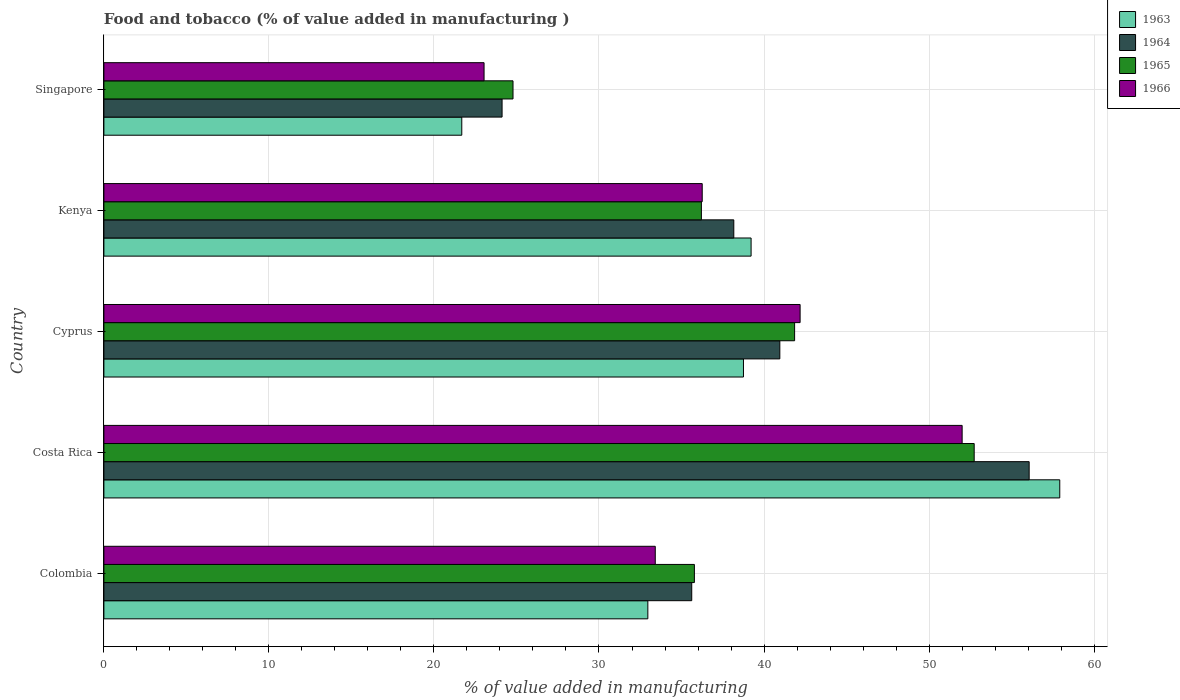How many different coloured bars are there?
Make the answer very short. 4. How many groups of bars are there?
Offer a terse response. 5. How many bars are there on the 5th tick from the top?
Provide a short and direct response. 4. How many bars are there on the 2nd tick from the bottom?
Make the answer very short. 4. What is the label of the 4th group of bars from the top?
Offer a very short reply. Costa Rica. What is the value added in manufacturing food and tobacco in 1963 in Kenya?
Make the answer very short. 39.22. Across all countries, what is the maximum value added in manufacturing food and tobacco in 1965?
Offer a terse response. 52.73. Across all countries, what is the minimum value added in manufacturing food and tobacco in 1963?
Give a very brief answer. 21.69. In which country was the value added in manufacturing food and tobacco in 1966 minimum?
Offer a terse response. Singapore. What is the total value added in manufacturing food and tobacco in 1963 in the graph?
Your response must be concise. 190.54. What is the difference between the value added in manufacturing food and tobacco in 1965 in Costa Rica and that in Kenya?
Ensure brevity in your answer.  16.53. What is the difference between the value added in manufacturing food and tobacco in 1966 in Kenya and the value added in manufacturing food and tobacco in 1964 in Costa Rica?
Make the answer very short. -19.81. What is the average value added in manufacturing food and tobacco in 1964 per country?
Make the answer very short. 38.99. What is the difference between the value added in manufacturing food and tobacco in 1964 and value added in manufacturing food and tobacco in 1965 in Costa Rica?
Your answer should be compact. 3.33. In how many countries, is the value added in manufacturing food and tobacco in 1964 greater than 38 %?
Offer a very short reply. 3. What is the ratio of the value added in manufacturing food and tobacco in 1964 in Cyprus to that in Kenya?
Your response must be concise. 1.07. Is the value added in manufacturing food and tobacco in 1963 in Costa Rica less than that in Kenya?
Offer a very short reply. No. What is the difference between the highest and the second highest value added in manufacturing food and tobacco in 1965?
Provide a succinct answer. 10.88. What is the difference between the highest and the lowest value added in manufacturing food and tobacco in 1964?
Provide a short and direct response. 31.94. What does the 4th bar from the top in Cyprus represents?
Give a very brief answer. 1963. What does the 4th bar from the bottom in Colombia represents?
Provide a succinct answer. 1966. Is it the case that in every country, the sum of the value added in manufacturing food and tobacco in 1963 and value added in manufacturing food and tobacco in 1964 is greater than the value added in manufacturing food and tobacco in 1966?
Give a very brief answer. Yes. How many bars are there?
Make the answer very short. 20. Are all the bars in the graph horizontal?
Your response must be concise. Yes. What is the difference between two consecutive major ticks on the X-axis?
Your answer should be compact. 10. Does the graph contain any zero values?
Offer a terse response. No. Where does the legend appear in the graph?
Make the answer very short. Top right. What is the title of the graph?
Make the answer very short. Food and tobacco (% of value added in manufacturing ). Does "1963" appear as one of the legend labels in the graph?
Make the answer very short. Yes. What is the label or title of the X-axis?
Keep it short and to the point. % of value added in manufacturing. What is the label or title of the Y-axis?
Provide a succinct answer. Country. What is the % of value added in manufacturing in 1963 in Colombia?
Your answer should be very brief. 32.96. What is the % of value added in manufacturing of 1964 in Colombia?
Make the answer very short. 35.62. What is the % of value added in manufacturing of 1965 in Colombia?
Your response must be concise. 35.78. What is the % of value added in manufacturing of 1966 in Colombia?
Provide a short and direct response. 33.41. What is the % of value added in manufacturing of 1963 in Costa Rica?
Make the answer very short. 57.92. What is the % of value added in manufacturing of 1964 in Costa Rica?
Make the answer very short. 56.07. What is the % of value added in manufacturing in 1965 in Costa Rica?
Your answer should be very brief. 52.73. What is the % of value added in manufacturing in 1966 in Costa Rica?
Provide a succinct answer. 52. What is the % of value added in manufacturing of 1963 in Cyprus?
Make the answer very short. 38.75. What is the % of value added in manufacturing of 1964 in Cyprus?
Your answer should be compact. 40.96. What is the % of value added in manufacturing in 1965 in Cyprus?
Provide a succinct answer. 41.85. What is the % of value added in manufacturing of 1966 in Cyprus?
Your answer should be compact. 42.19. What is the % of value added in manufacturing in 1963 in Kenya?
Give a very brief answer. 39.22. What is the % of value added in manufacturing of 1964 in Kenya?
Offer a terse response. 38.17. What is the % of value added in manufacturing of 1965 in Kenya?
Your response must be concise. 36.2. What is the % of value added in manufacturing of 1966 in Kenya?
Offer a terse response. 36.25. What is the % of value added in manufacturing of 1963 in Singapore?
Keep it short and to the point. 21.69. What is the % of value added in manufacturing in 1964 in Singapore?
Make the answer very short. 24.13. What is the % of value added in manufacturing of 1965 in Singapore?
Provide a short and direct response. 24.79. What is the % of value added in manufacturing in 1966 in Singapore?
Give a very brief answer. 23.04. Across all countries, what is the maximum % of value added in manufacturing of 1963?
Offer a terse response. 57.92. Across all countries, what is the maximum % of value added in manufacturing of 1964?
Provide a short and direct response. 56.07. Across all countries, what is the maximum % of value added in manufacturing in 1965?
Your answer should be compact. 52.73. Across all countries, what is the maximum % of value added in manufacturing of 1966?
Offer a terse response. 52. Across all countries, what is the minimum % of value added in manufacturing of 1963?
Your response must be concise. 21.69. Across all countries, what is the minimum % of value added in manufacturing in 1964?
Make the answer very short. 24.13. Across all countries, what is the minimum % of value added in manufacturing in 1965?
Your answer should be compact. 24.79. Across all countries, what is the minimum % of value added in manufacturing of 1966?
Offer a terse response. 23.04. What is the total % of value added in manufacturing of 1963 in the graph?
Offer a terse response. 190.54. What is the total % of value added in manufacturing in 1964 in the graph?
Make the answer very short. 194.94. What is the total % of value added in manufacturing of 1965 in the graph?
Keep it short and to the point. 191.36. What is the total % of value added in manufacturing of 1966 in the graph?
Your answer should be compact. 186.89. What is the difference between the % of value added in manufacturing in 1963 in Colombia and that in Costa Rica?
Provide a short and direct response. -24.96. What is the difference between the % of value added in manufacturing of 1964 in Colombia and that in Costa Rica?
Provide a succinct answer. -20.45. What is the difference between the % of value added in manufacturing of 1965 in Colombia and that in Costa Rica?
Give a very brief answer. -16.95. What is the difference between the % of value added in manufacturing in 1966 in Colombia and that in Costa Rica?
Provide a succinct answer. -18.59. What is the difference between the % of value added in manufacturing of 1963 in Colombia and that in Cyprus?
Offer a very short reply. -5.79. What is the difference between the % of value added in manufacturing of 1964 in Colombia and that in Cyprus?
Offer a very short reply. -5.34. What is the difference between the % of value added in manufacturing of 1965 in Colombia and that in Cyprus?
Give a very brief answer. -6.07. What is the difference between the % of value added in manufacturing in 1966 in Colombia and that in Cyprus?
Provide a succinct answer. -8.78. What is the difference between the % of value added in manufacturing in 1963 in Colombia and that in Kenya?
Offer a very short reply. -6.26. What is the difference between the % of value added in manufacturing in 1964 in Colombia and that in Kenya?
Offer a terse response. -2.55. What is the difference between the % of value added in manufacturing in 1965 in Colombia and that in Kenya?
Give a very brief answer. -0.42. What is the difference between the % of value added in manufacturing of 1966 in Colombia and that in Kenya?
Ensure brevity in your answer.  -2.84. What is the difference between the % of value added in manufacturing of 1963 in Colombia and that in Singapore?
Make the answer very short. 11.27. What is the difference between the % of value added in manufacturing of 1964 in Colombia and that in Singapore?
Provide a succinct answer. 11.49. What is the difference between the % of value added in manufacturing in 1965 in Colombia and that in Singapore?
Ensure brevity in your answer.  10.99. What is the difference between the % of value added in manufacturing in 1966 in Colombia and that in Singapore?
Your answer should be compact. 10.37. What is the difference between the % of value added in manufacturing in 1963 in Costa Rica and that in Cyprus?
Give a very brief answer. 19.17. What is the difference between the % of value added in manufacturing of 1964 in Costa Rica and that in Cyprus?
Offer a terse response. 15.11. What is the difference between the % of value added in manufacturing of 1965 in Costa Rica and that in Cyprus?
Provide a succinct answer. 10.88. What is the difference between the % of value added in manufacturing of 1966 in Costa Rica and that in Cyprus?
Keep it short and to the point. 9.82. What is the difference between the % of value added in manufacturing in 1963 in Costa Rica and that in Kenya?
Your response must be concise. 18.7. What is the difference between the % of value added in manufacturing in 1964 in Costa Rica and that in Kenya?
Offer a terse response. 17.9. What is the difference between the % of value added in manufacturing in 1965 in Costa Rica and that in Kenya?
Make the answer very short. 16.53. What is the difference between the % of value added in manufacturing in 1966 in Costa Rica and that in Kenya?
Ensure brevity in your answer.  15.75. What is the difference between the % of value added in manufacturing in 1963 in Costa Rica and that in Singapore?
Make the answer very short. 36.23. What is the difference between the % of value added in manufacturing of 1964 in Costa Rica and that in Singapore?
Give a very brief answer. 31.94. What is the difference between the % of value added in manufacturing of 1965 in Costa Rica and that in Singapore?
Provide a succinct answer. 27.94. What is the difference between the % of value added in manufacturing of 1966 in Costa Rica and that in Singapore?
Give a very brief answer. 28.97. What is the difference between the % of value added in manufacturing of 1963 in Cyprus and that in Kenya?
Give a very brief answer. -0.46. What is the difference between the % of value added in manufacturing in 1964 in Cyprus and that in Kenya?
Offer a very short reply. 2.79. What is the difference between the % of value added in manufacturing of 1965 in Cyprus and that in Kenya?
Give a very brief answer. 5.65. What is the difference between the % of value added in manufacturing in 1966 in Cyprus and that in Kenya?
Your answer should be compact. 5.93. What is the difference between the % of value added in manufacturing in 1963 in Cyprus and that in Singapore?
Keep it short and to the point. 17.07. What is the difference between the % of value added in manufacturing in 1964 in Cyprus and that in Singapore?
Offer a terse response. 16.83. What is the difference between the % of value added in manufacturing in 1965 in Cyprus and that in Singapore?
Your response must be concise. 17.06. What is the difference between the % of value added in manufacturing in 1966 in Cyprus and that in Singapore?
Provide a succinct answer. 19.15. What is the difference between the % of value added in manufacturing in 1963 in Kenya and that in Singapore?
Make the answer very short. 17.53. What is the difference between the % of value added in manufacturing of 1964 in Kenya and that in Singapore?
Offer a terse response. 14.04. What is the difference between the % of value added in manufacturing in 1965 in Kenya and that in Singapore?
Your answer should be very brief. 11.41. What is the difference between the % of value added in manufacturing of 1966 in Kenya and that in Singapore?
Offer a terse response. 13.22. What is the difference between the % of value added in manufacturing in 1963 in Colombia and the % of value added in manufacturing in 1964 in Costa Rica?
Your response must be concise. -23.11. What is the difference between the % of value added in manufacturing of 1963 in Colombia and the % of value added in manufacturing of 1965 in Costa Rica?
Your answer should be very brief. -19.77. What is the difference between the % of value added in manufacturing in 1963 in Colombia and the % of value added in manufacturing in 1966 in Costa Rica?
Provide a short and direct response. -19.04. What is the difference between the % of value added in manufacturing in 1964 in Colombia and the % of value added in manufacturing in 1965 in Costa Rica?
Give a very brief answer. -17.11. What is the difference between the % of value added in manufacturing of 1964 in Colombia and the % of value added in manufacturing of 1966 in Costa Rica?
Offer a very short reply. -16.38. What is the difference between the % of value added in manufacturing in 1965 in Colombia and the % of value added in manufacturing in 1966 in Costa Rica?
Ensure brevity in your answer.  -16.22. What is the difference between the % of value added in manufacturing in 1963 in Colombia and the % of value added in manufacturing in 1964 in Cyprus?
Your answer should be compact. -8. What is the difference between the % of value added in manufacturing of 1963 in Colombia and the % of value added in manufacturing of 1965 in Cyprus?
Keep it short and to the point. -8.89. What is the difference between the % of value added in manufacturing of 1963 in Colombia and the % of value added in manufacturing of 1966 in Cyprus?
Your answer should be compact. -9.23. What is the difference between the % of value added in manufacturing of 1964 in Colombia and the % of value added in manufacturing of 1965 in Cyprus?
Your answer should be compact. -6.23. What is the difference between the % of value added in manufacturing of 1964 in Colombia and the % of value added in manufacturing of 1966 in Cyprus?
Ensure brevity in your answer.  -6.57. What is the difference between the % of value added in manufacturing of 1965 in Colombia and the % of value added in manufacturing of 1966 in Cyprus?
Ensure brevity in your answer.  -6.41. What is the difference between the % of value added in manufacturing in 1963 in Colombia and the % of value added in manufacturing in 1964 in Kenya?
Keep it short and to the point. -5.21. What is the difference between the % of value added in manufacturing in 1963 in Colombia and the % of value added in manufacturing in 1965 in Kenya?
Give a very brief answer. -3.24. What is the difference between the % of value added in manufacturing in 1963 in Colombia and the % of value added in manufacturing in 1966 in Kenya?
Ensure brevity in your answer.  -3.29. What is the difference between the % of value added in manufacturing of 1964 in Colombia and the % of value added in manufacturing of 1965 in Kenya?
Provide a short and direct response. -0.58. What is the difference between the % of value added in manufacturing in 1964 in Colombia and the % of value added in manufacturing in 1966 in Kenya?
Offer a very short reply. -0.63. What is the difference between the % of value added in manufacturing in 1965 in Colombia and the % of value added in manufacturing in 1966 in Kenya?
Provide a short and direct response. -0.47. What is the difference between the % of value added in manufacturing in 1963 in Colombia and the % of value added in manufacturing in 1964 in Singapore?
Make the answer very short. 8.83. What is the difference between the % of value added in manufacturing of 1963 in Colombia and the % of value added in manufacturing of 1965 in Singapore?
Offer a terse response. 8.17. What is the difference between the % of value added in manufacturing of 1963 in Colombia and the % of value added in manufacturing of 1966 in Singapore?
Your answer should be very brief. 9.92. What is the difference between the % of value added in manufacturing in 1964 in Colombia and the % of value added in manufacturing in 1965 in Singapore?
Your answer should be compact. 10.83. What is the difference between the % of value added in manufacturing in 1964 in Colombia and the % of value added in manufacturing in 1966 in Singapore?
Provide a succinct answer. 12.58. What is the difference between the % of value added in manufacturing of 1965 in Colombia and the % of value added in manufacturing of 1966 in Singapore?
Offer a terse response. 12.74. What is the difference between the % of value added in manufacturing in 1963 in Costa Rica and the % of value added in manufacturing in 1964 in Cyprus?
Provide a short and direct response. 16.96. What is the difference between the % of value added in manufacturing of 1963 in Costa Rica and the % of value added in manufacturing of 1965 in Cyprus?
Ensure brevity in your answer.  16.07. What is the difference between the % of value added in manufacturing in 1963 in Costa Rica and the % of value added in manufacturing in 1966 in Cyprus?
Offer a very short reply. 15.73. What is the difference between the % of value added in manufacturing of 1964 in Costa Rica and the % of value added in manufacturing of 1965 in Cyprus?
Ensure brevity in your answer.  14.21. What is the difference between the % of value added in manufacturing of 1964 in Costa Rica and the % of value added in manufacturing of 1966 in Cyprus?
Your response must be concise. 13.88. What is the difference between the % of value added in manufacturing of 1965 in Costa Rica and the % of value added in manufacturing of 1966 in Cyprus?
Offer a terse response. 10.55. What is the difference between the % of value added in manufacturing of 1963 in Costa Rica and the % of value added in manufacturing of 1964 in Kenya?
Your answer should be compact. 19.75. What is the difference between the % of value added in manufacturing of 1963 in Costa Rica and the % of value added in manufacturing of 1965 in Kenya?
Keep it short and to the point. 21.72. What is the difference between the % of value added in manufacturing in 1963 in Costa Rica and the % of value added in manufacturing in 1966 in Kenya?
Your answer should be very brief. 21.67. What is the difference between the % of value added in manufacturing of 1964 in Costa Rica and the % of value added in manufacturing of 1965 in Kenya?
Keep it short and to the point. 19.86. What is the difference between the % of value added in manufacturing in 1964 in Costa Rica and the % of value added in manufacturing in 1966 in Kenya?
Make the answer very short. 19.81. What is the difference between the % of value added in manufacturing of 1965 in Costa Rica and the % of value added in manufacturing of 1966 in Kenya?
Provide a succinct answer. 16.48. What is the difference between the % of value added in manufacturing of 1963 in Costa Rica and the % of value added in manufacturing of 1964 in Singapore?
Keep it short and to the point. 33.79. What is the difference between the % of value added in manufacturing in 1963 in Costa Rica and the % of value added in manufacturing in 1965 in Singapore?
Give a very brief answer. 33.13. What is the difference between the % of value added in manufacturing of 1963 in Costa Rica and the % of value added in manufacturing of 1966 in Singapore?
Provide a succinct answer. 34.88. What is the difference between the % of value added in manufacturing in 1964 in Costa Rica and the % of value added in manufacturing in 1965 in Singapore?
Your answer should be compact. 31.28. What is the difference between the % of value added in manufacturing of 1964 in Costa Rica and the % of value added in manufacturing of 1966 in Singapore?
Your response must be concise. 33.03. What is the difference between the % of value added in manufacturing in 1965 in Costa Rica and the % of value added in manufacturing in 1966 in Singapore?
Give a very brief answer. 29.7. What is the difference between the % of value added in manufacturing of 1963 in Cyprus and the % of value added in manufacturing of 1964 in Kenya?
Your answer should be compact. 0.59. What is the difference between the % of value added in manufacturing of 1963 in Cyprus and the % of value added in manufacturing of 1965 in Kenya?
Offer a very short reply. 2.55. What is the difference between the % of value added in manufacturing in 1963 in Cyprus and the % of value added in manufacturing in 1966 in Kenya?
Keep it short and to the point. 2.5. What is the difference between the % of value added in manufacturing of 1964 in Cyprus and the % of value added in manufacturing of 1965 in Kenya?
Keep it short and to the point. 4.75. What is the difference between the % of value added in manufacturing of 1964 in Cyprus and the % of value added in manufacturing of 1966 in Kenya?
Ensure brevity in your answer.  4.7. What is the difference between the % of value added in manufacturing in 1965 in Cyprus and the % of value added in manufacturing in 1966 in Kenya?
Provide a short and direct response. 5.6. What is the difference between the % of value added in manufacturing in 1963 in Cyprus and the % of value added in manufacturing in 1964 in Singapore?
Your response must be concise. 14.63. What is the difference between the % of value added in manufacturing of 1963 in Cyprus and the % of value added in manufacturing of 1965 in Singapore?
Ensure brevity in your answer.  13.96. What is the difference between the % of value added in manufacturing of 1963 in Cyprus and the % of value added in manufacturing of 1966 in Singapore?
Provide a short and direct response. 15.72. What is the difference between the % of value added in manufacturing of 1964 in Cyprus and the % of value added in manufacturing of 1965 in Singapore?
Give a very brief answer. 16.17. What is the difference between the % of value added in manufacturing of 1964 in Cyprus and the % of value added in manufacturing of 1966 in Singapore?
Your response must be concise. 17.92. What is the difference between the % of value added in manufacturing of 1965 in Cyprus and the % of value added in manufacturing of 1966 in Singapore?
Ensure brevity in your answer.  18.82. What is the difference between the % of value added in manufacturing in 1963 in Kenya and the % of value added in manufacturing in 1964 in Singapore?
Your answer should be compact. 15.09. What is the difference between the % of value added in manufacturing in 1963 in Kenya and the % of value added in manufacturing in 1965 in Singapore?
Ensure brevity in your answer.  14.43. What is the difference between the % of value added in manufacturing in 1963 in Kenya and the % of value added in manufacturing in 1966 in Singapore?
Offer a very short reply. 16.18. What is the difference between the % of value added in manufacturing of 1964 in Kenya and the % of value added in manufacturing of 1965 in Singapore?
Ensure brevity in your answer.  13.38. What is the difference between the % of value added in manufacturing in 1964 in Kenya and the % of value added in manufacturing in 1966 in Singapore?
Offer a terse response. 15.13. What is the difference between the % of value added in manufacturing of 1965 in Kenya and the % of value added in manufacturing of 1966 in Singapore?
Give a very brief answer. 13.17. What is the average % of value added in manufacturing in 1963 per country?
Keep it short and to the point. 38.11. What is the average % of value added in manufacturing in 1964 per country?
Your response must be concise. 38.99. What is the average % of value added in manufacturing in 1965 per country?
Give a very brief answer. 38.27. What is the average % of value added in manufacturing of 1966 per country?
Give a very brief answer. 37.38. What is the difference between the % of value added in manufacturing in 1963 and % of value added in manufacturing in 1964 in Colombia?
Keep it short and to the point. -2.66. What is the difference between the % of value added in manufacturing of 1963 and % of value added in manufacturing of 1965 in Colombia?
Keep it short and to the point. -2.82. What is the difference between the % of value added in manufacturing of 1963 and % of value added in manufacturing of 1966 in Colombia?
Your response must be concise. -0.45. What is the difference between the % of value added in manufacturing in 1964 and % of value added in manufacturing in 1965 in Colombia?
Give a very brief answer. -0.16. What is the difference between the % of value added in manufacturing in 1964 and % of value added in manufacturing in 1966 in Colombia?
Make the answer very short. 2.21. What is the difference between the % of value added in manufacturing in 1965 and % of value added in manufacturing in 1966 in Colombia?
Ensure brevity in your answer.  2.37. What is the difference between the % of value added in manufacturing in 1963 and % of value added in manufacturing in 1964 in Costa Rica?
Offer a terse response. 1.85. What is the difference between the % of value added in manufacturing in 1963 and % of value added in manufacturing in 1965 in Costa Rica?
Make the answer very short. 5.19. What is the difference between the % of value added in manufacturing in 1963 and % of value added in manufacturing in 1966 in Costa Rica?
Keep it short and to the point. 5.92. What is the difference between the % of value added in manufacturing in 1964 and % of value added in manufacturing in 1965 in Costa Rica?
Keep it short and to the point. 3.33. What is the difference between the % of value added in manufacturing of 1964 and % of value added in manufacturing of 1966 in Costa Rica?
Your response must be concise. 4.06. What is the difference between the % of value added in manufacturing in 1965 and % of value added in manufacturing in 1966 in Costa Rica?
Provide a succinct answer. 0.73. What is the difference between the % of value added in manufacturing in 1963 and % of value added in manufacturing in 1964 in Cyprus?
Give a very brief answer. -2.2. What is the difference between the % of value added in manufacturing in 1963 and % of value added in manufacturing in 1965 in Cyprus?
Your response must be concise. -3.1. What is the difference between the % of value added in manufacturing in 1963 and % of value added in manufacturing in 1966 in Cyprus?
Ensure brevity in your answer.  -3.43. What is the difference between the % of value added in manufacturing in 1964 and % of value added in manufacturing in 1965 in Cyprus?
Make the answer very short. -0.9. What is the difference between the % of value added in manufacturing in 1964 and % of value added in manufacturing in 1966 in Cyprus?
Ensure brevity in your answer.  -1.23. What is the difference between the % of value added in manufacturing in 1963 and % of value added in manufacturing in 1964 in Kenya?
Your answer should be very brief. 1.05. What is the difference between the % of value added in manufacturing in 1963 and % of value added in manufacturing in 1965 in Kenya?
Your answer should be very brief. 3.01. What is the difference between the % of value added in manufacturing of 1963 and % of value added in manufacturing of 1966 in Kenya?
Ensure brevity in your answer.  2.96. What is the difference between the % of value added in manufacturing of 1964 and % of value added in manufacturing of 1965 in Kenya?
Offer a terse response. 1.96. What is the difference between the % of value added in manufacturing of 1964 and % of value added in manufacturing of 1966 in Kenya?
Offer a terse response. 1.91. What is the difference between the % of value added in manufacturing in 1965 and % of value added in manufacturing in 1966 in Kenya?
Your response must be concise. -0.05. What is the difference between the % of value added in manufacturing in 1963 and % of value added in manufacturing in 1964 in Singapore?
Provide a short and direct response. -2.44. What is the difference between the % of value added in manufacturing of 1963 and % of value added in manufacturing of 1965 in Singapore?
Your response must be concise. -3.1. What is the difference between the % of value added in manufacturing of 1963 and % of value added in manufacturing of 1966 in Singapore?
Your response must be concise. -1.35. What is the difference between the % of value added in manufacturing in 1964 and % of value added in manufacturing in 1965 in Singapore?
Your answer should be very brief. -0.66. What is the difference between the % of value added in manufacturing of 1964 and % of value added in manufacturing of 1966 in Singapore?
Your answer should be very brief. 1.09. What is the difference between the % of value added in manufacturing of 1965 and % of value added in manufacturing of 1966 in Singapore?
Your response must be concise. 1.75. What is the ratio of the % of value added in manufacturing in 1963 in Colombia to that in Costa Rica?
Provide a succinct answer. 0.57. What is the ratio of the % of value added in manufacturing of 1964 in Colombia to that in Costa Rica?
Give a very brief answer. 0.64. What is the ratio of the % of value added in manufacturing in 1965 in Colombia to that in Costa Rica?
Ensure brevity in your answer.  0.68. What is the ratio of the % of value added in manufacturing in 1966 in Colombia to that in Costa Rica?
Offer a very short reply. 0.64. What is the ratio of the % of value added in manufacturing in 1963 in Colombia to that in Cyprus?
Keep it short and to the point. 0.85. What is the ratio of the % of value added in manufacturing of 1964 in Colombia to that in Cyprus?
Offer a very short reply. 0.87. What is the ratio of the % of value added in manufacturing of 1965 in Colombia to that in Cyprus?
Ensure brevity in your answer.  0.85. What is the ratio of the % of value added in manufacturing of 1966 in Colombia to that in Cyprus?
Your answer should be very brief. 0.79. What is the ratio of the % of value added in manufacturing in 1963 in Colombia to that in Kenya?
Give a very brief answer. 0.84. What is the ratio of the % of value added in manufacturing in 1964 in Colombia to that in Kenya?
Your response must be concise. 0.93. What is the ratio of the % of value added in manufacturing of 1965 in Colombia to that in Kenya?
Provide a short and direct response. 0.99. What is the ratio of the % of value added in manufacturing in 1966 in Colombia to that in Kenya?
Give a very brief answer. 0.92. What is the ratio of the % of value added in manufacturing in 1963 in Colombia to that in Singapore?
Make the answer very short. 1.52. What is the ratio of the % of value added in manufacturing of 1964 in Colombia to that in Singapore?
Provide a short and direct response. 1.48. What is the ratio of the % of value added in manufacturing of 1965 in Colombia to that in Singapore?
Ensure brevity in your answer.  1.44. What is the ratio of the % of value added in manufacturing of 1966 in Colombia to that in Singapore?
Keep it short and to the point. 1.45. What is the ratio of the % of value added in manufacturing of 1963 in Costa Rica to that in Cyprus?
Offer a terse response. 1.49. What is the ratio of the % of value added in manufacturing of 1964 in Costa Rica to that in Cyprus?
Make the answer very short. 1.37. What is the ratio of the % of value added in manufacturing of 1965 in Costa Rica to that in Cyprus?
Your response must be concise. 1.26. What is the ratio of the % of value added in manufacturing in 1966 in Costa Rica to that in Cyprus?
Provide a succinct answer. 1.23. What is the ratio of the % of value added in manufacturing of 1963 in Costa Rica to that in Kenya?
Your answer should be very brief. 1.48. What is the ratio of the % of value added in manufacturing of 1964 in Costa Rica to that in Kenya?
Provide a short and direct response. 1.47. What is the ratio of the % of value added in manufacturing in 1965 in Costa Rica to that in Kenya?
Provide a short and direct response. 1.46. What is the ratio of the % of value added in manufacturing in 1966 in Costa Rica to that in Kenya?
Your response must be concise. 1.43. What is the ratio of the % of value added in manufacturing in 1963 in Costa Rica to that in Singapore?
Give a very brief answer. 2.67. What is the ratio of the % of value added in manufacturing of 1964 in Costa Rica to that in Singapore?
Your response must be concise. 2.32. What is the ratio of the % of value added in manufacturing of 1965 in Costa Rica to that in Singapore?
Give a very brief answer. 2.13. What is the ratio of the % of value added in manufacturing of 1966 in Costa Rica to that in Singapore?
Make the answer very short. 2.26. What is the ratio of the % of value added in manufacturing of 1964 in Cyprus to that in Kenya?
Your answer should be very brief. 1.07. What is the ratio of the % of value added in manufacturing in 1965 in Cyprus to that in Kenya?
Provide a succinct answer. 1.16. What is the ratio of the % of value added in manufacturing in 1966 in Cyprus to that in Kenya?
Make the answer very short. 1.16. What is the ratio of the % of value added in manufacturing in 1963 in Cyprus to that in Singapore?
Your answer should be very brief. 1.79. What is the ratio of the % of value added in manufacturing of 1964 in Cyprus to that in Singapore?
Your answer should be very brief. 1.7. What is the ratio of the % of value added in manufacturing of 1965 in Cyprus to that in Singapore?
Your answer should be very brief. 1.69. What is the ratio of the % of value added in manufacturing in 1966 in Cyprus to that in Singapore?
Your response must be concise. 1.83. What is the ratio of the % of value added in manufacturing of 1963 in Kenya to that in Singapore?
Make the answer very short. 1.81. What is the ratio of the % of value added in manufacturing of 1964 in Kenya to that in Singapore?
Offer a terse response. 1.58. What is the ratio of the % of value added in manufacturing of 1965 in Kenya to that in Singapore?
Ensure brevity in your answer.  1.46. What is the ratio of the % of value added in manufacturing of 1966 in Kenya to that in Singapore?
Your response must be concise. 1.57. What is the difference between the highest and the second highest % of value added in manufacturing of 1963?
Ensure brevity in your answer.  18.7. What is the difference between the highest and the second highest % of value added in manufacturing in 1964?
Give a very brief answer. 15.11. What is the difference between the highest and the second highest % of value added in manufacturing of 1965?
Keep it short and to the point. 10.88. What is the difference between the highest and the second highest % of value added in manufacturing of 1966?
Provide a short and direct response. 9.82. What is the difference between the highest and the lowest % of value added in manufacturing in 1963?
Your answer should be compact. 36.23. What is the difference between the highest and the lowest % of value added in manufacturing in 1964?
Offer a very short reply. 31.94. What is the difference between the highest and the lowest % of value added in manufacturing in 1965?
Make the answer very short. 27.94. What is the difference between the highest and the lowest % of value added in manufacturing in 1966?
Give a very brief answer. 28.97. 